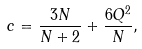<formula> <loc_0><loc_0><loc_500><loc_500>c = \frac { 3 N } { N + 2 } + \frac { 6 Q ^ { 2 } } { N } ,</formula> 